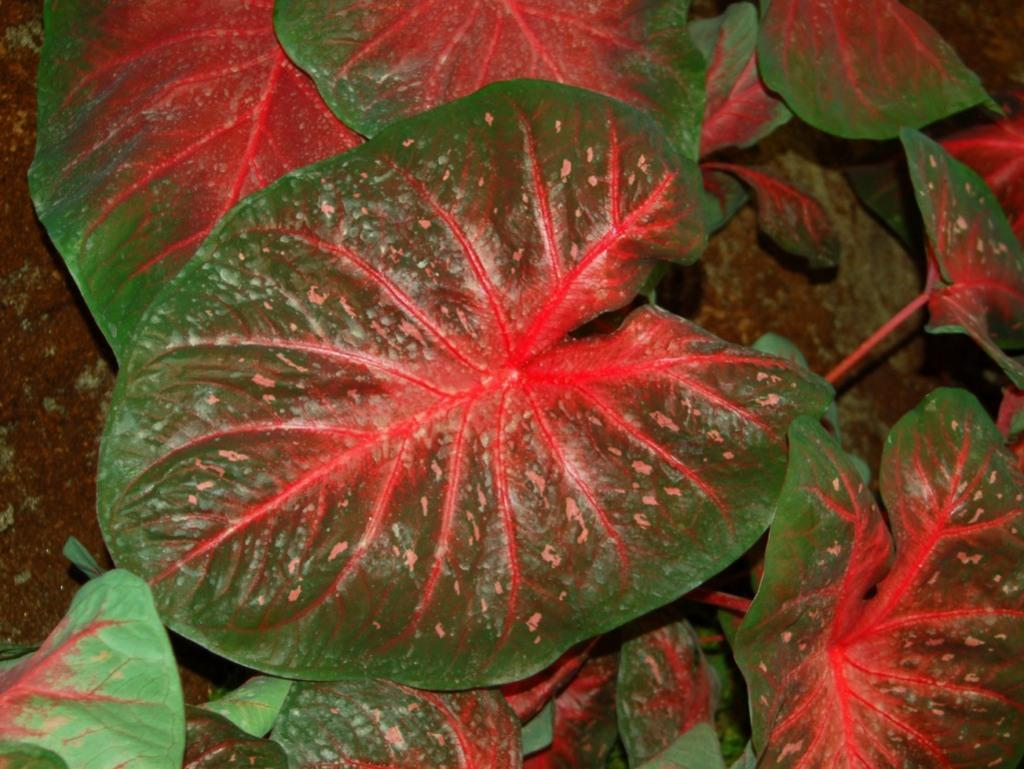What is located in the middle of the image? There are big leaves in the middle of the image. What can be observed on the leaves? There are red lines on the leaves. What type of cushion is being used as a vegetable in the image? There is no cushion or vegetable present in the image; it only features big leaves with red lines on them. 